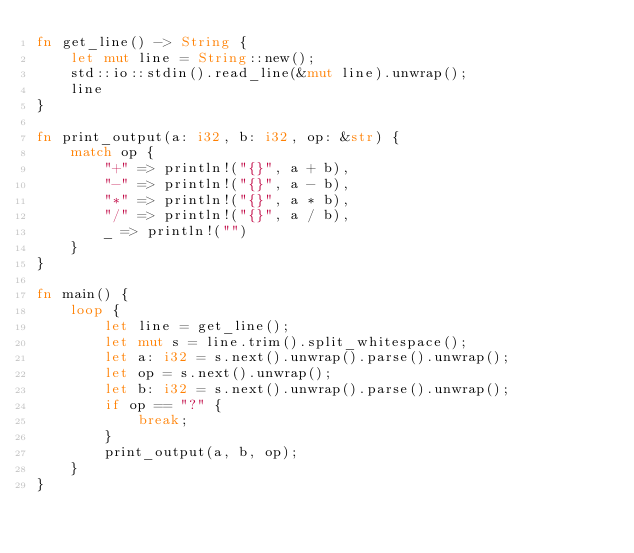<code> <loc_0><loc_0><loc_500><loc_500><_Rust_>fn get_line() -> String {
    let mut line = String::new();
    std::io::stdin().read_line(&mut line).unwrap();
    line
}

fn print_output(a: i32, b: i32, op: &str) {
    match op {
        "+" => println!("{}", a + b),
        "-" => println!("{}", a - b),
        "*" => println!("{}", a * b),
        "/" => println!("{}", a / b),
        _ => println!("")
    }
}

fn main() {
    loop {
        let line = get_line();
        let mut s = line.trim().split_whitespace();
        let a: i32 = s.next().unwrap().parse().unwrap();
        let op = s.next().unwrap();
        let b: i32 = s.next().unwrap().parse().unwrap();
        if op == "?" {
            break;
        }
        print_output(a, b, op);
    }
}

</code> 